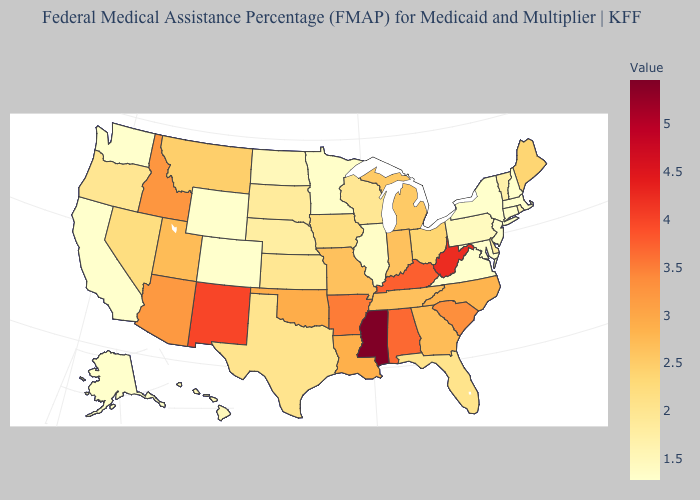Does the map have missing data?
Short answer required. No. Which states have the lowest value in the Northeast?
Be succinct. Connecticut, Massachusetts, New Hampshire, New Jersey, New York. Does New Mexico have the lowest value in the USA?
Be succinct. No. Is the legend a continuous bar?
Keep it brief. Yes. Among the states that border Mississippi , which have the highest value?
Keep it brief. Alabama. Which states have the lowest value in the USA?
Give a very brief answer. Alaska, California, Colorado, Connecticut, Maryland, Massachusetts, New Hampshire, New Jersey, New York, Virginia, Washington, Wyoming. Does New Hampshire have the lowest value in the USA?
Short answer required. Yes. 